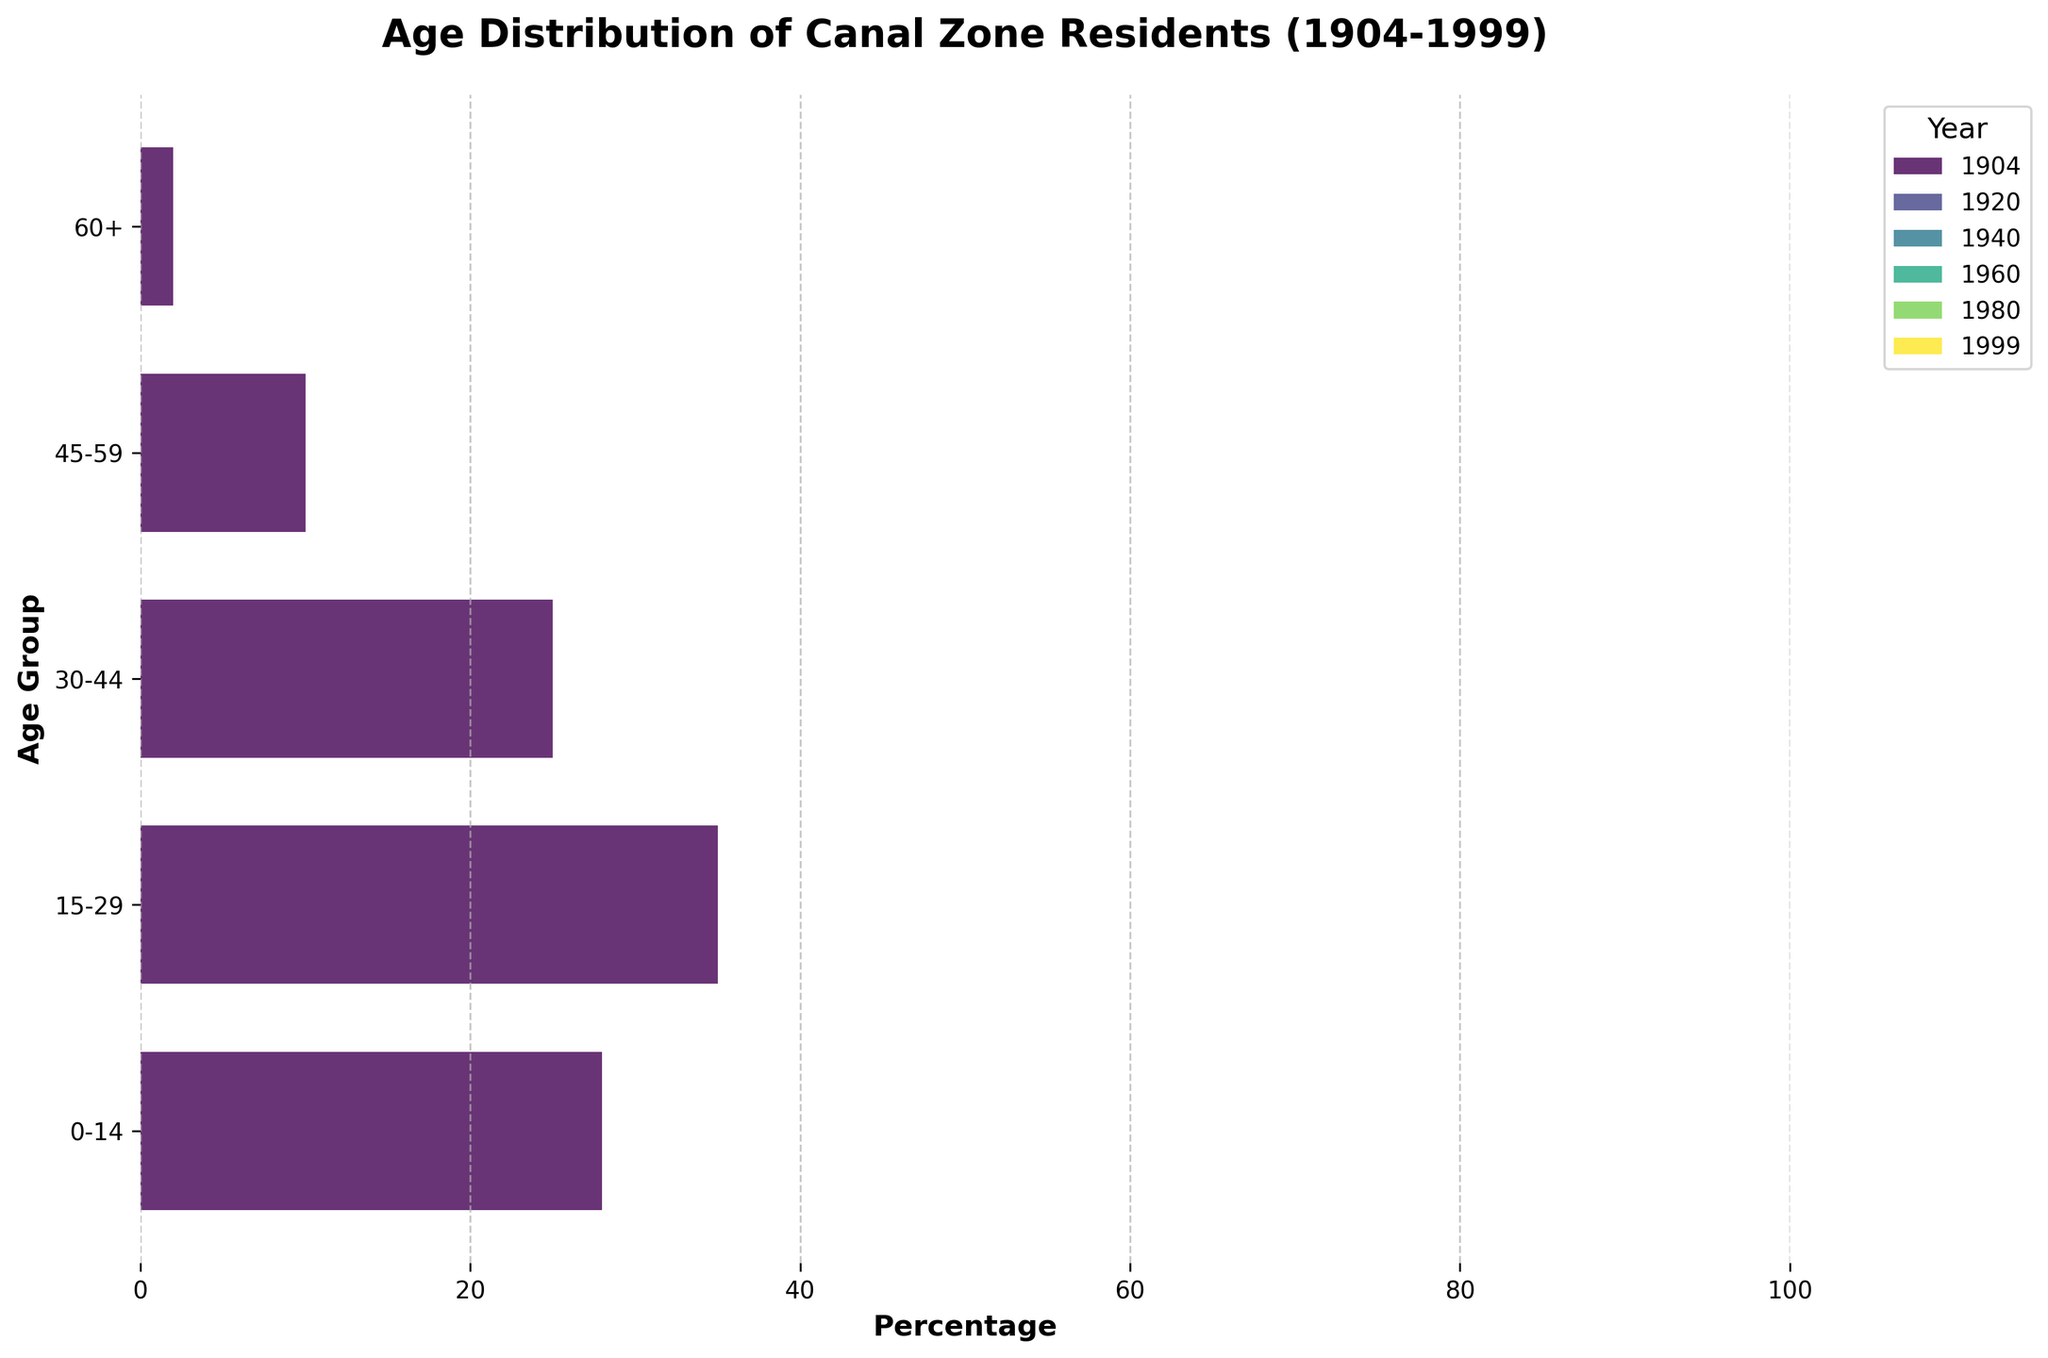When does the age group 0-14 have the highest percentage? To answer this, we need to look at the bars corresponding to the age group 0-14 in the plot and identify the year with the longest bar. The longest bar for the age group 0-14 is in the year 1960.
Answer: 1960 What is the trend for the percentage of residents aged 60+ from 1904 to 1999? We should examine the bars for the age group 60+ across the different years and observe how they change over time. The percentage increases from 2% in 1904 to 5% in 1999, showing a gradual increase.
Answer: gradual increase Which year has the lowest percentage for the age group 15-29? By comparing the length of bars for the age group 15-29 across all years, we observe that the shortest bar is in the year 1960, where it's 22%.
Answer: 1960 In which year does the percentage of residents aged 45-59 first reach 15% or more? Observing the bars for the age group 45-59, we see that in 1940 the percentage is 15%, which is the first time it reaches or exceeds this value.
Answer: 1940 How does the age distribution change between 1980 and 1999 for the age group 0-14? Compare the bars for the age group 0-14 in the years 1980 and 1999. The percentage decreases from 30% in 1980 to 25% in 1999.
Answer: decreases What is the combined percentage of residents aged 0-14 and 15-29 in the year 1999? We need to sum the percentages of the age groups 0-14 and 15-29 for the year 1999. The percentages are 25% and 28%, respectively. 25% + 28% = 53%.
Answer: 53% Which age group shows the most significant decline from 1960 to 1999? By comparing the percentages for each age group in 1960 and 1999, we see that the age group 0-14 decreases from 38% to 25%, which is a 13% decline.
Answer: 0-14 How does the percentage of the age group 30-44 change from 1920 to 1940? Look at the bars for the age group 30-44 in 1920 and 1940. The percentage decreases from 23% in 1920 to 22% in 1940.
Answer: decreases What is the difference in percentage for the age group 45-59 between 1904 and 1999? Subtract the percentage of the age group 45-59 in 1904 (10%) from the percentage in 1999 (18%). 18% - 10% = 8%.
Answer: 8% Which age group has a higher percentage in 1980 compared to 1904? By comparing the bars in 1980 and 1904, we see that the age groups 45-59 (17% in 1980 vs. 10% in 1904) and 60+ (5% in 1980 vs. 2% in 1904) have higher percentages in 1980.
Answer: 45-59 and 60+ 